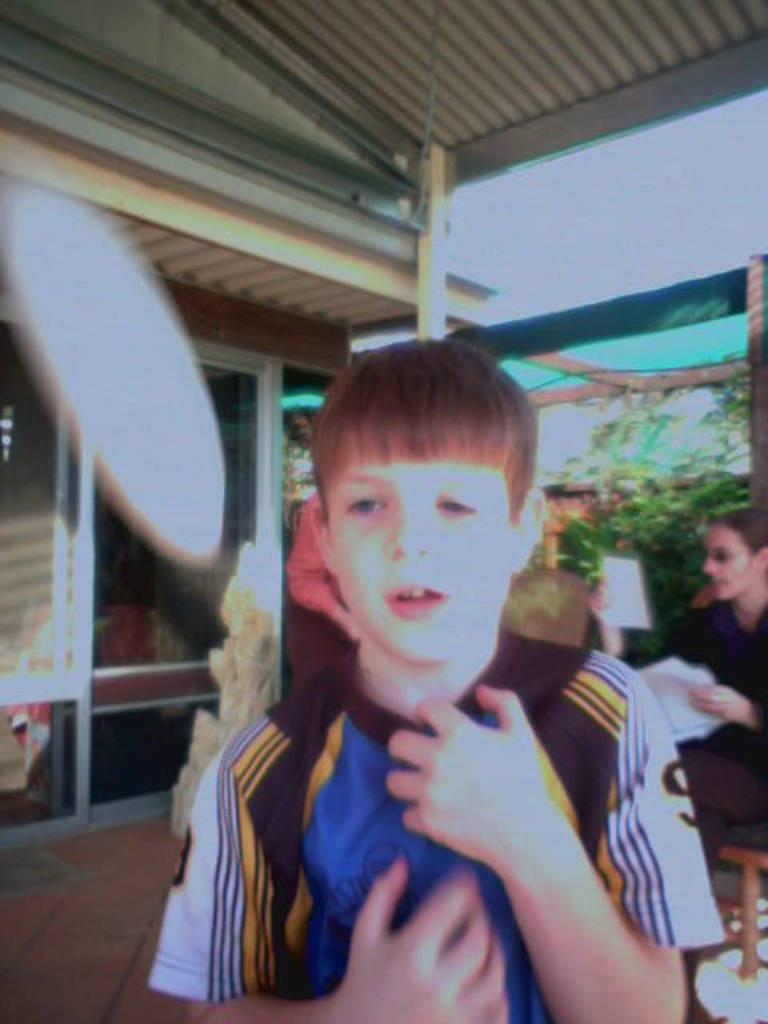What is the main subject of the image? There is a boy standing in the center of the image. What can be seen in the background of the image? There are trees, persons, buildings, and the sky visible in the background of the image. What type of fang can be seen on the shelf in the image? There is no shelf or fang present in the image. 